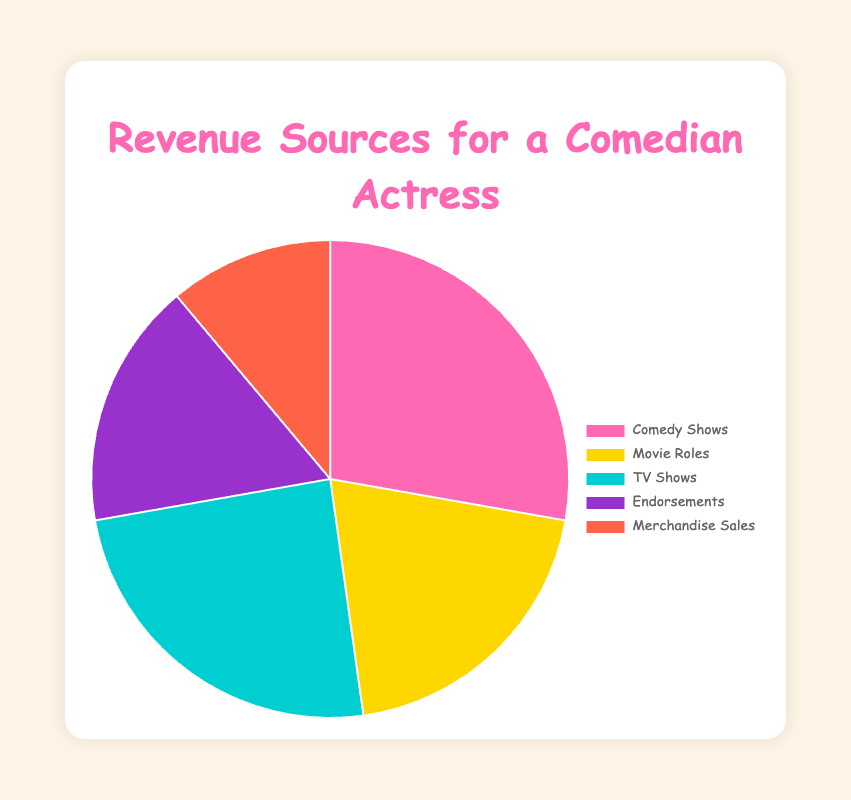Which revenue source contributes the most to the total revenue? The pie chart shows various revenue sources, and the segment labeled "Comedy Shows" is the largest, indicating it has the highest revenue.
Answer: Comedy Shows Which revenue source has the least contribution to the total revenue? The segment labeled "Merchandise Sales" is the smallest, which indicates this source contributes the least to the total revenue.
Answer: Merchandise Sales What is the total revenue generated from TV Shows and Movie Roles combined? According to the chart, TV Shows generate $2,200,000, and Movie Roles generate $1,800,000. Adding these amounts gives $2,200,000 + $1,800,000 = $4,000,000.
Answer: $4,000,000 How much more revenue do Comedy Shows generate compared to Endorsements? Comedy Shows generate $2,500,000, while Endorsements generate $1,500,000. Subtracting the two gives $2,500,000 - $1,500,000 = $1,000,000.
Answer: $1,000,000 What percentage of the total revenue is generated by Merchandising Sales? The total revenue is the sum of all sources: $2,500,000 (Comedy Shows) + $1,800,000 (Movie Roles) + $2,200,000 (TV Shows) + $1,500,000 (Endorsements) + $1,000,000 (Merchandising Sales) = $9,000,000. The percentage from Merchandising Sales is ($1,000,000 / $9,000,000) * 100 = 11.1%.
Answer: 11.1% Is the revenue from TV Shows less than or equal to the combined revenue of Movie Roles and Endorsements? TV Shows generate $2,200,000. The combined revenue of Movie Roles ($1,800,000) and Endorsements ($1,500,000) is $1,800,000 + $1,500,000 = $3,300,000. Since $2,200,000 is less than $3,300,000, the statement is true.
Answer: Yes By how much does the revenue from Movie Roles exceed the revenue from Merchandise Sales? Movie Roles generate $1,800,000, and Merchandise Sales generate $1,000,000. The difference is $1,800,000 - $1,000,000 = $800,000.
Answer: $800,000 What is the average revenue from the five sources? The total revenue is $9,000,000. Dividing this by the five sources gives $9,000,000 / 5 = $1,800,000.
Answer: $1,800,000 